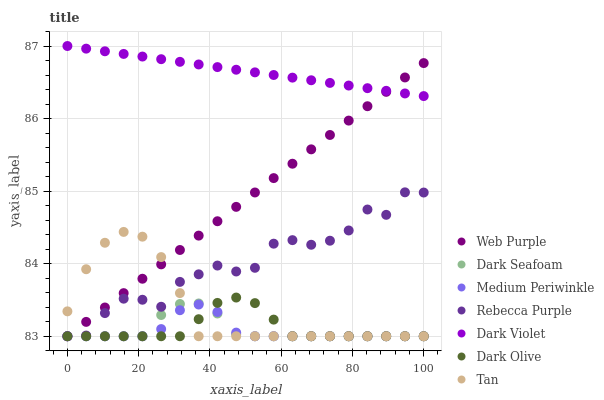Does Medium Periwinkle have the minimum area under the curve?
Answer yes or no. Yes. Does Dark Violet have the maximum area under the curve?
Answer yes or no. Yes. Does Dark Seafoam have the minimum area under the curve?
Answer yes or no. No. Does Dark Seafoam have the maximum area under the curve?
Answer yes or no. No. Is Dark Violet the smoothest?
Answer yes or no. Yes. Is Rebecca Purple the roughest?
Answer yes or no. Yes. Is Medium Periwinkle the smoothest?
Answer yes or no. No. Is Medium Periwinkle the roughest?
Answer yes or no. No. Does Dark Olive have the lowest value?
Answer yes or no. Yes. Does Dark Violet have the lowest value?
Answer yes or no. No. Does Dark Violet have the highest value?
Answer yes or no. Yes. Does Dark Seafoam have the highest value?
Answer yes or no. No. Is Dark Seafoam less than Dark Violet?
Answer yes or no. Yes. Is Dark Violet greater than Medium Periwinkle?
Answer yes or no. Yes. Does Dark Olive intersect Medium Periwinkle?
Answer yes or no. Yes. Is Dark Olive less than Medium Periwinkle?
Answer yes or no. No. Is Dark Olive greater than Medium Periwinkle?
Answer yes or no. No. Does Dark Seafoam intersect Dark Violet?
Answer yes or no. No. 